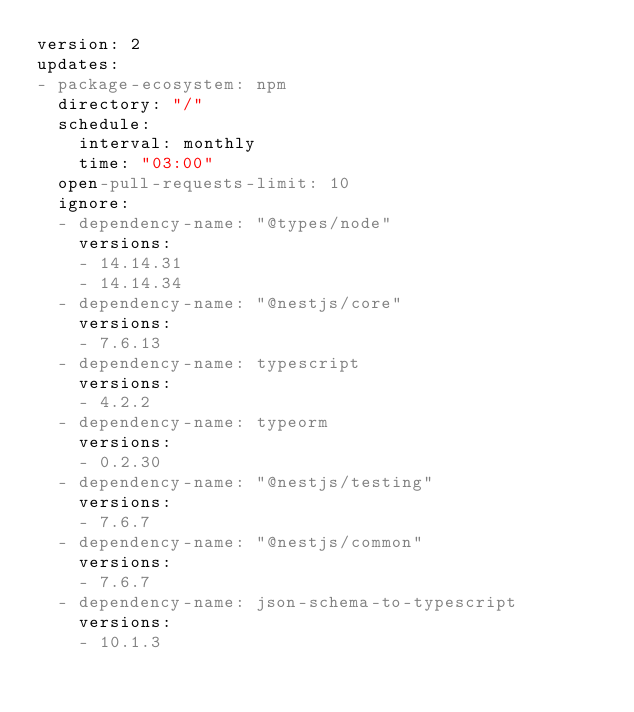Convert code to text. <code><loc_0><loc_0><loc_500><loc_500><_YAML_>version: 2
updates:
- package-ecosystem: npm
  directory: "/"
  schedule:
    interval: monthly
    time: "03:00"
  open-pull-requests-limit: 10
  ignore:
  - dependency-name: "@types/node"
    versions:
    - 14.14.31
    - 14.14.34
  - dependency-name: "@nestjs/core"
    versions:
    - 7.6.13
  - dependency-name: typescript
    versions:
    - 4.2.2
  - dependency-name: typeorm
    versions:
    - 0.2.30
  - dependency-name: "@nestjs/testing"
    versions:
    - 7.6.7
  - dependency-name: "@nestjs/common"
    versions:
    - 7.6.7
  - dependency-name: json-schema-to-typescript
    versions:
    - 10.1.3
</code> 